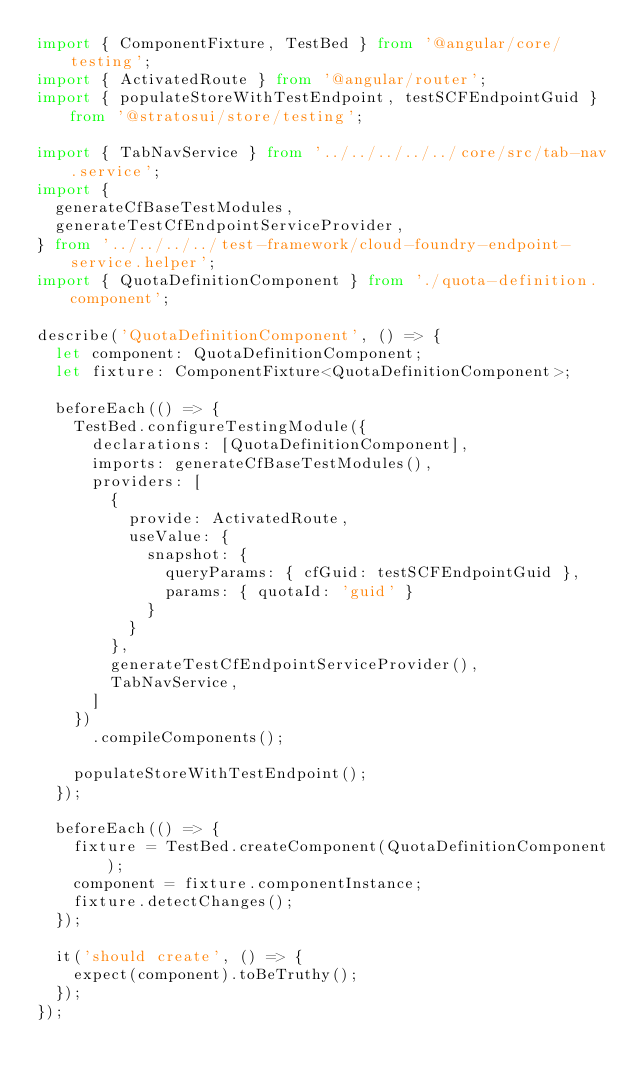<code> <loc_0><loc_0><loc_500><loc_500><_TypeScript_>import { ComponentFixture, TestBed } from '@angular/core/testing';
import { ActivatedRoute } from '@angular/router';
import { populateStoreWithTestEndpoint, testSCFEndpointGuid } from '@stratosui/store/testing';

import { TabNavService } from '../../../../../core/src/tab-nav.service';
import {
  generateCfBaseTestModules,
  generateTestCfEndpointServiceProvider,
} from '../../../../test-framework/cloud-foundry-endpoint-service.helper';
import { QuotaDefinitionComponent } from './quota-definition.component';

describe('QuotaDefinitionComponent', () => {
  let component: QuotaDefinitionComponent;
  let fixture: ComponentFixture<QuotaDefinitionComponent>;

  beforeEach(() => {
    TestBed.configureTestingModule({
      declarations: [QuotaDefinitionComponent],
      imports: generateCfBaseTestModules(),
      providers: [
        {
          provide: ActivatedRoute,
          useValue: {
            snapshot: {
              queryParams: { cfGuid: testSCFEndpointGuid },
              params: { quotaId: 'guid' }
            }
          }
        },
        generateTestCfEndpointServiceProvider(),
        TabNavService,
      ]
    })
      .compileComponents();

    populateStoreWithTestEndpoint();
  });

  beforeEach(() => {
    fixture = TestBed.createComponent(QuotaDefinitionComponent);
    component = fixture.componentInstance;
    fixture.detectChanges();
  });

  it('should create', () => {
    expect(component).toBeTruthy();
  });
});
</code> 